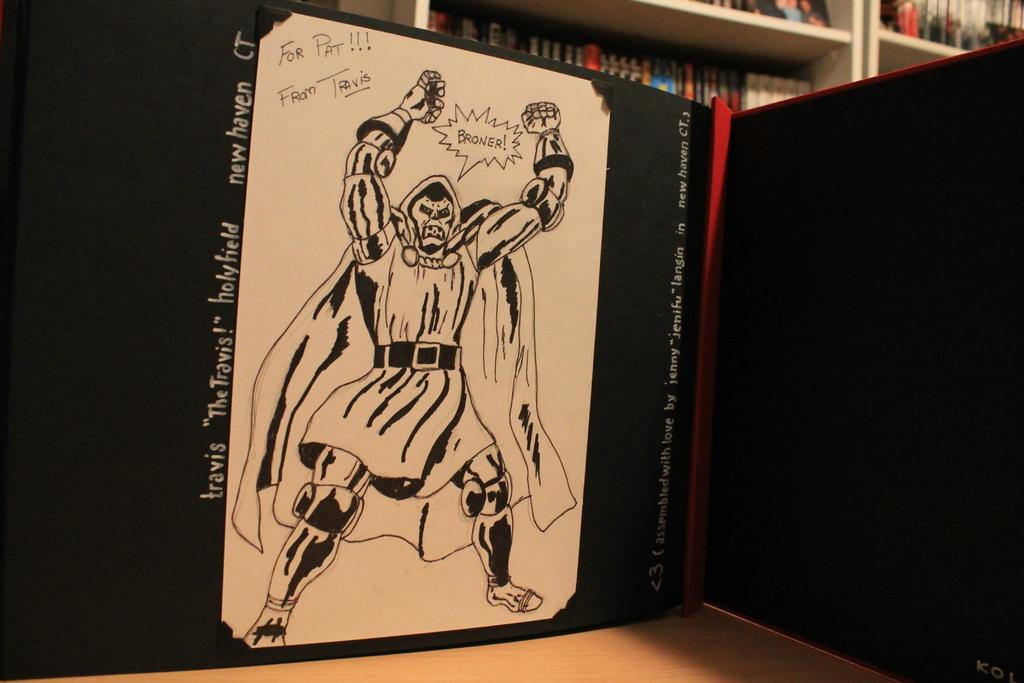Provide a one-sentence caption for the provided image. A drawing of Doctor Doom that was done for Pat. 